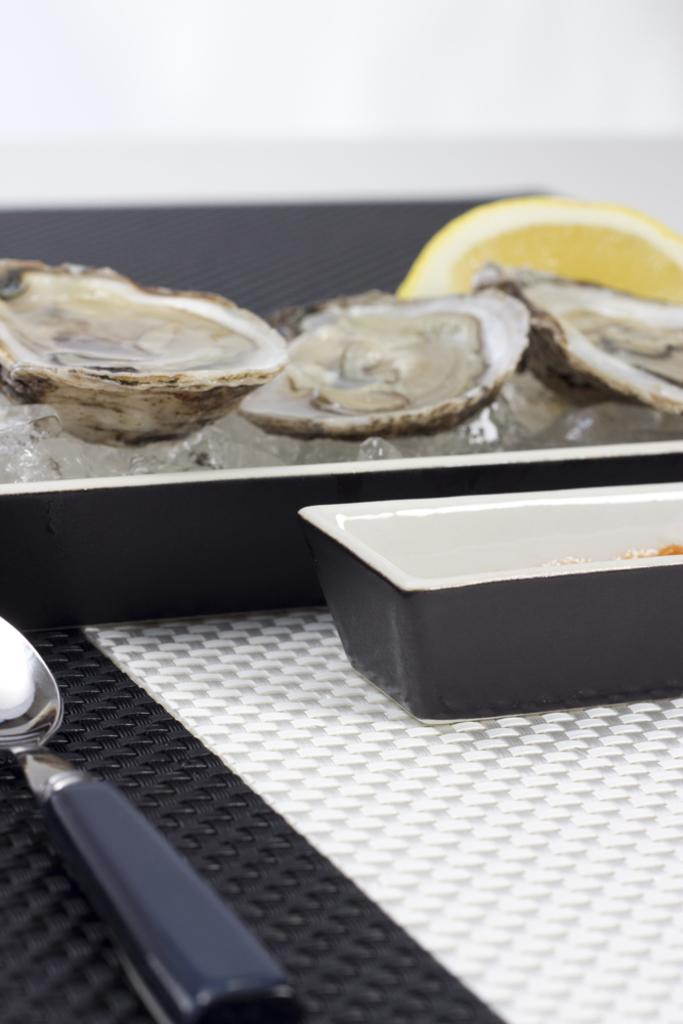What is the main piece of furniture in the image? There is a table in the image. What type of food can be seen on the table? Oysters are present on the table. What is used to keep the food cold on the table? Ice cubes are visible on the table. What is the platter used for on the table? The platter is used to hold food on the table. What is the bowl used for on the table? The bowl is used to hold food or other items on the table. What utensil is visible on the table? A spoon is visible on the table. What other objects can be seen on the table? There are other objects on the table, but their specific details are not mentioned in the facts. How many children are playing with the key and grape in the image? There are no children, key, or grape present in the image. 